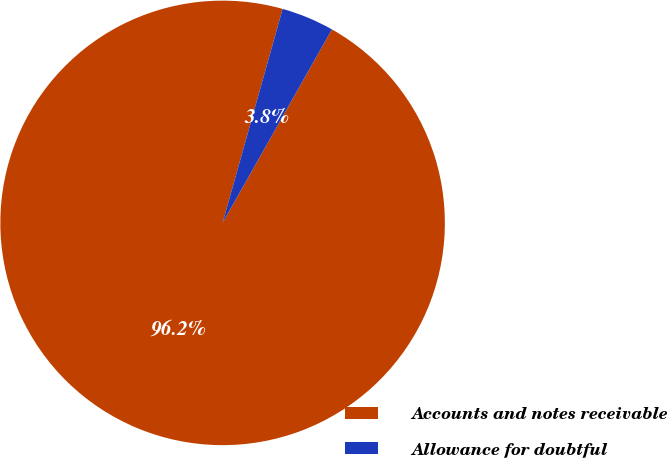Convert chart. <chart><loc_0><loc_0><loc_500><loc_500><pie_chart><fcel>Accounts and notes receivable<fcel>Allowance for doubtful<nl><fcel>96.17%<fcel>3.83%<nl></chart> 